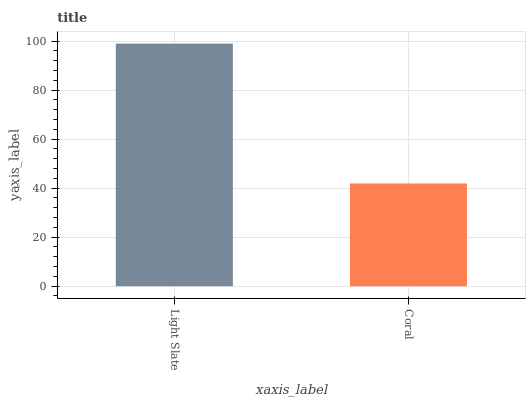Is Coral the minimum?
Answer yes or no. Yes. Is Light Slate the maximum?
Answer yes or no. Yes. Is Coral the maximum?
Answer yes or no. No. Is Light Slate greater than Coral?
Answer yes or no. Yes. Is Coral less than Light Slate?
Answer yes or no. Yes. Is Coral greater than Light Slate?
Answer yes or no. No. Is Light Slate less than Coral?
Answer yes or no. No. Is Light Slate the high median?
Answer yes or no. Yes. Is Coral the low median?
Answer yes or no. Yes. Is Coral the high median?
Answer yes or no. No. Is Light Slate the low median?
Answer yes or no. No. 